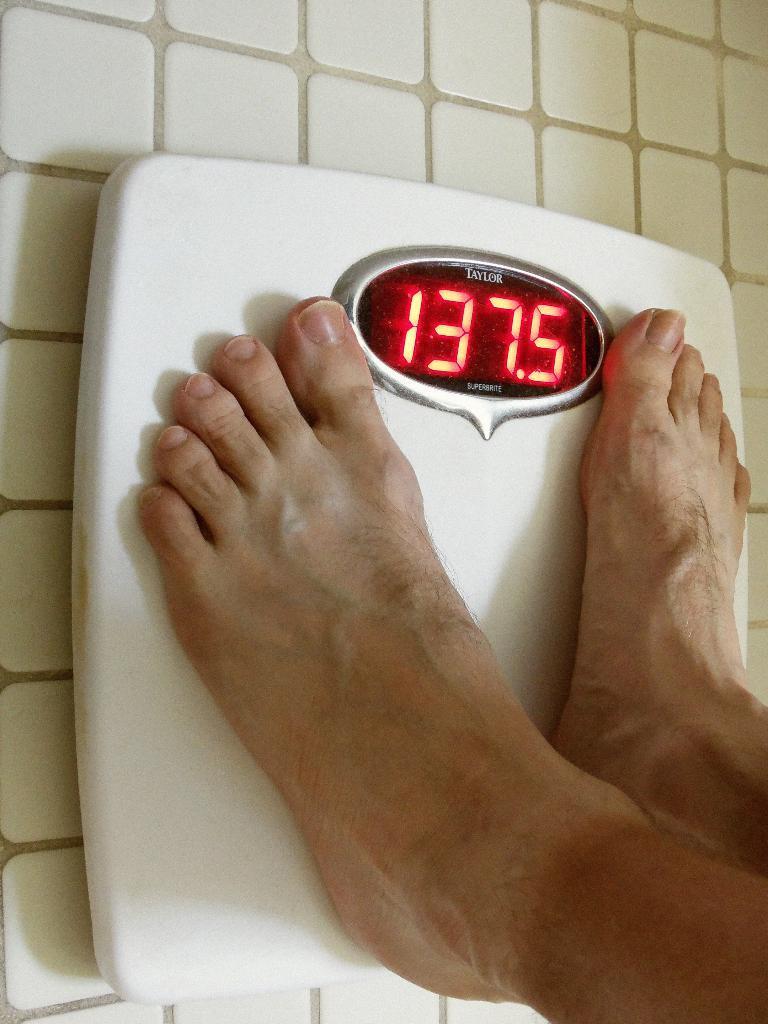How would you summarize this image in a sentence or two? In this image, we can see a person standing on the weighing machine and in the background, there is a floor. 